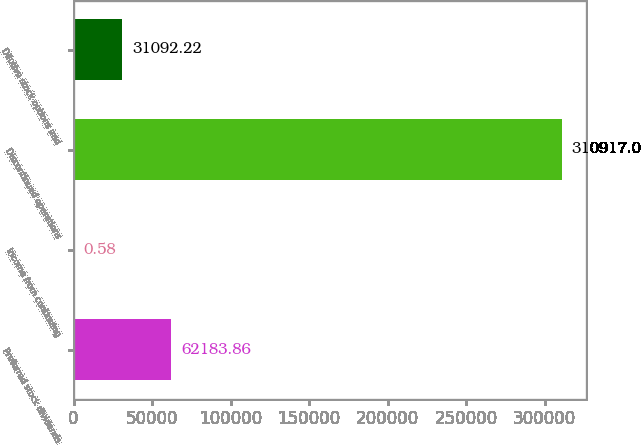<chart> <loc_0><loc_0><loc_500><loc_500><bar_chart><fcel>Preferred stock dividends<fcel>Income from continuing<fcel>Discontinued operations<fcel>Dilutive stock options and<nl><fcel>62183.9<fcel>0.58<fcel>310917<fcel>31092.2<nl></chart> 